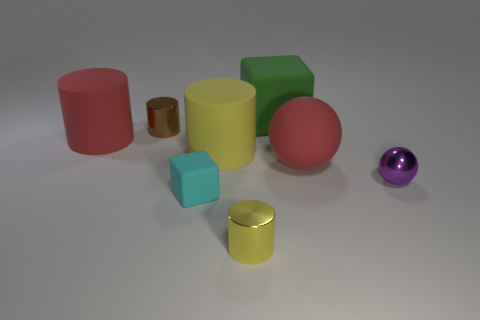Is there any other thing of the same color as the large matte sphere? Yes, the smaller sphere to the right of the large one appears to have a similar hue of purple, although differing in size and material finish. 